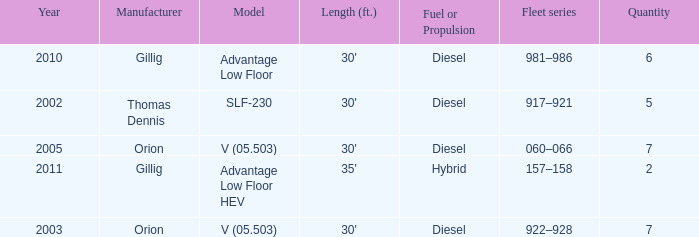Name the fleet series with a quantity of 5 917–921. 